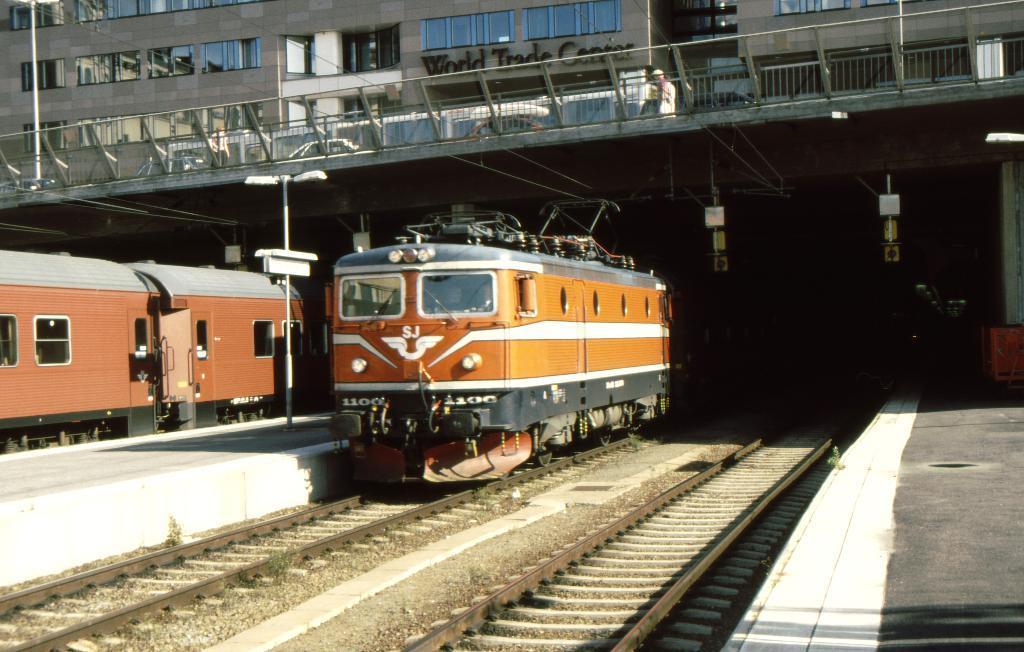Describe this image in one or two sentences. This image consists of trains. It looks like a railway station. At the bottom, there are tracks. To the right, there is a platform. At the top, there is a foot over bridge. In the background, there is a building. 